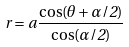<formula> <loc_0><loc_0><loc_500><loc_500>r = a \frac { \cos ( \theta + \alpha / 2 ) } { \cos ( \alpha / 2 ) }</formula> 